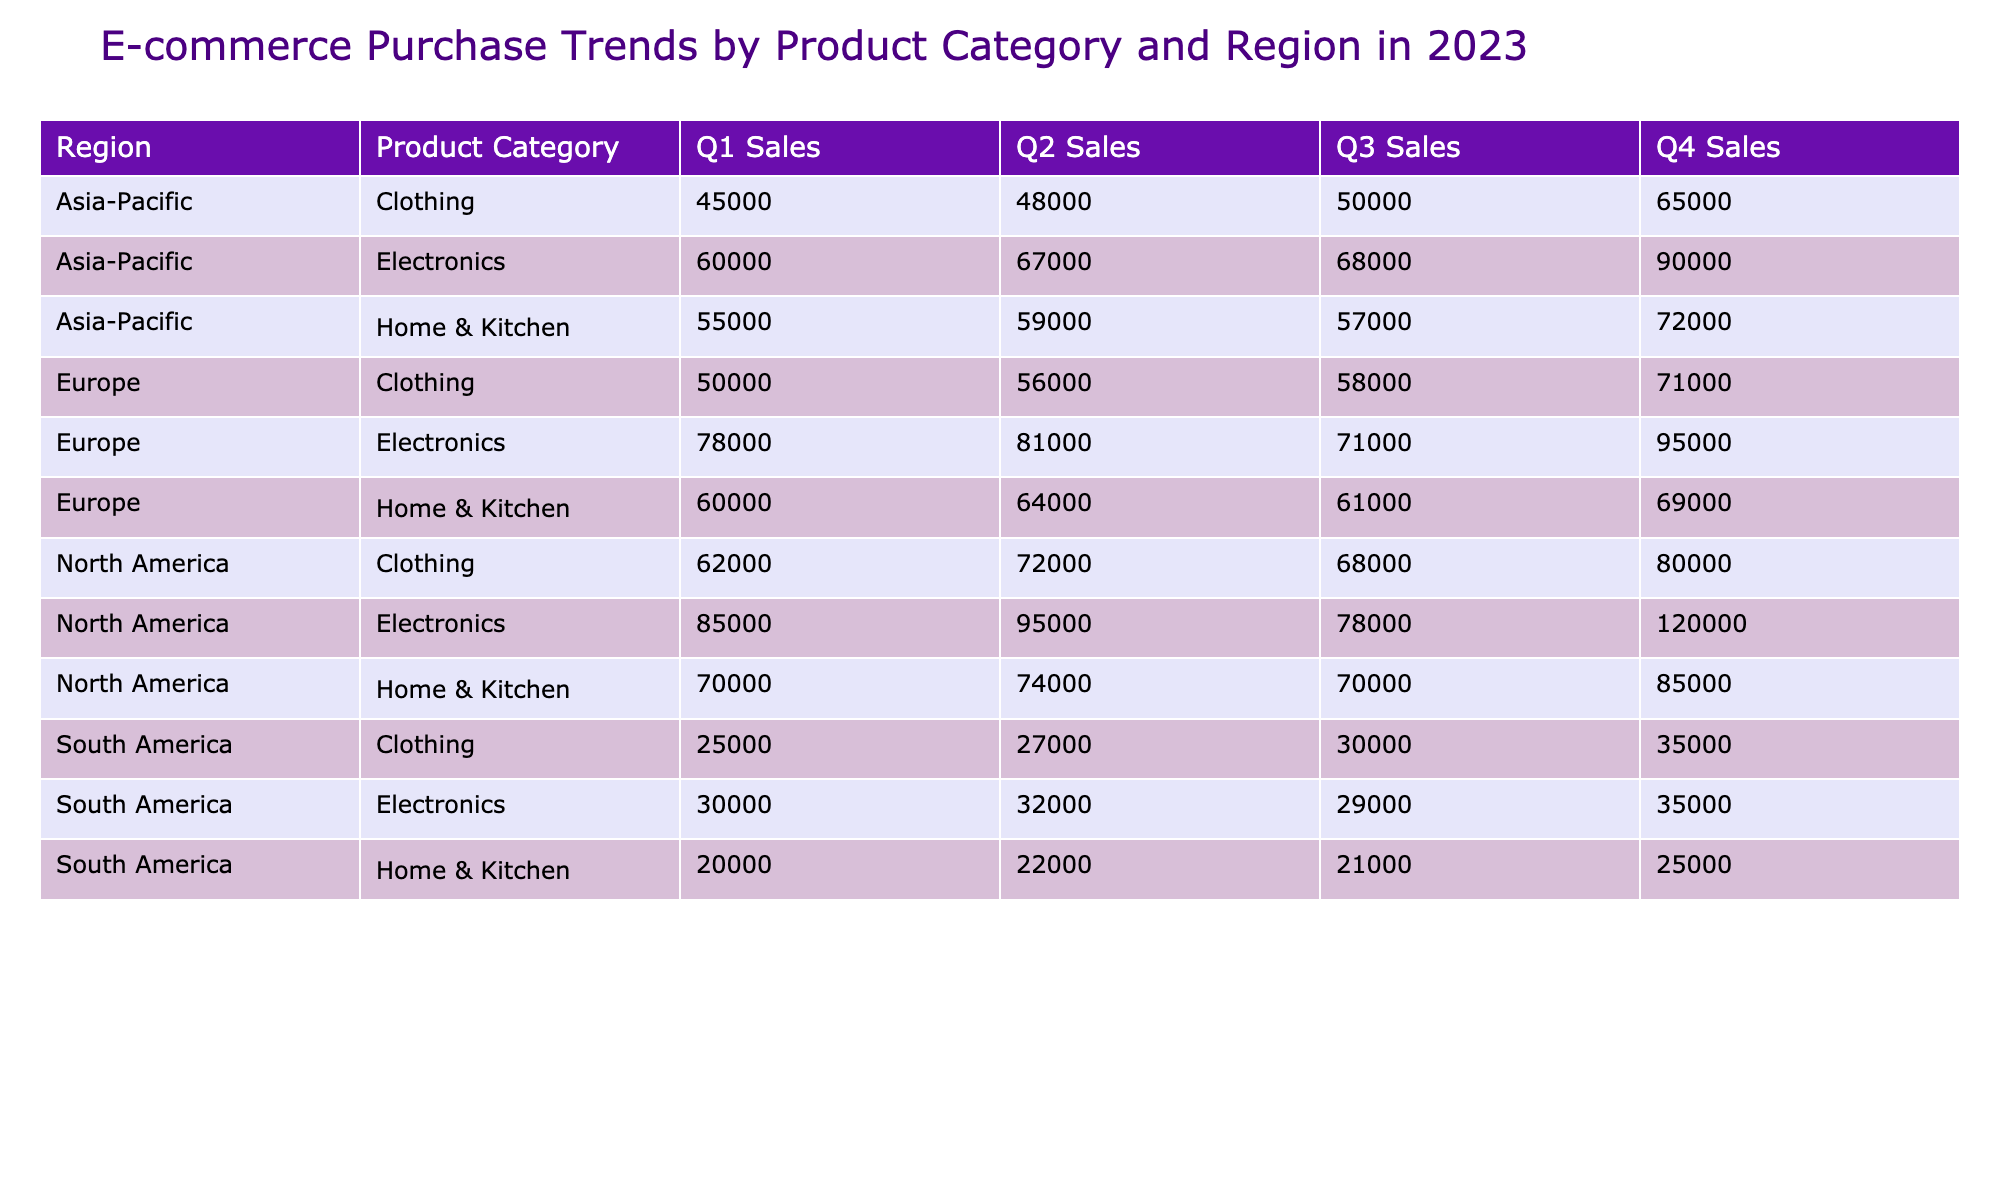What were the Q2 sales for Electronics in North America? The table shows that the Q2 sales for Electronics in North America are listed directly as 95000.
Answer: 95000 Which product category had the highest Q4 sales in Asia-Pacific? The Q4 sales figures for Asia-Pacific indicate that Electronics had the highest sales at 90000, compared to Clothing at 65000 and Home & Kitchen at 72000.
Answer: Electronics What is the total sales for Clothing in South America across all four quarters? To find the total sales for Clothing in South America, we add the sales figures: 25000 + 27000 + 30000 + 35000 = 117000.
Answer: 117000 Did Home & Kitchen sales ever exceed 80000 in Q1 across all regions? By inspecting the data, Home & Kitchen sales in Q1 are: 70000 (North America), 60000 (Europe), 55000 (Asia-Pacific), and 20000 (South America). None of these exceed 80000.
Answer: No What is the average Q1 sales across all product categories in Europe? The Q1 sales figures for Europe are: Electronics (78000), Clothing (50000), and Home & Kitchen (60000). The total is 78000 + 50000 + 60000 = 188000, and the average is 188000 / 3 = 62666.67.
Answer: 62666.67 Which region had the lowest total sales in Q3 when compared to others? The Q3 sales totals are: North America (68000 + 70000 + 78000 = 216000), Europe (71000 + 61000 + 58000 = 190000), Asia-Pacific (68000 + 50000 + 57000 = 185000), and South America (29000 + 30000 + 21000 = 80000). South America has the lowest total at 80000.
Answer: South America What was the difference between the Q4 sales of Electronics and Home & Kitchen in North America? The Q4 sales for Electronics in North America are 120000, and for Home & Kitchen, it is 85000. The difference is 120000 - 85000 = 35000.
Answer: 35000 Is the total sales for Electronics across all regions higher than that for Clothing? Adding the Q4 sales for Electronics totals 85000 + 78000 + 60000 + 30000 = 253000, while for Clothing it is 62000 + 50000 + 45000 + 25000 = 187000. Since 253000 > 187000, the statement is true.
Answer: Yes 